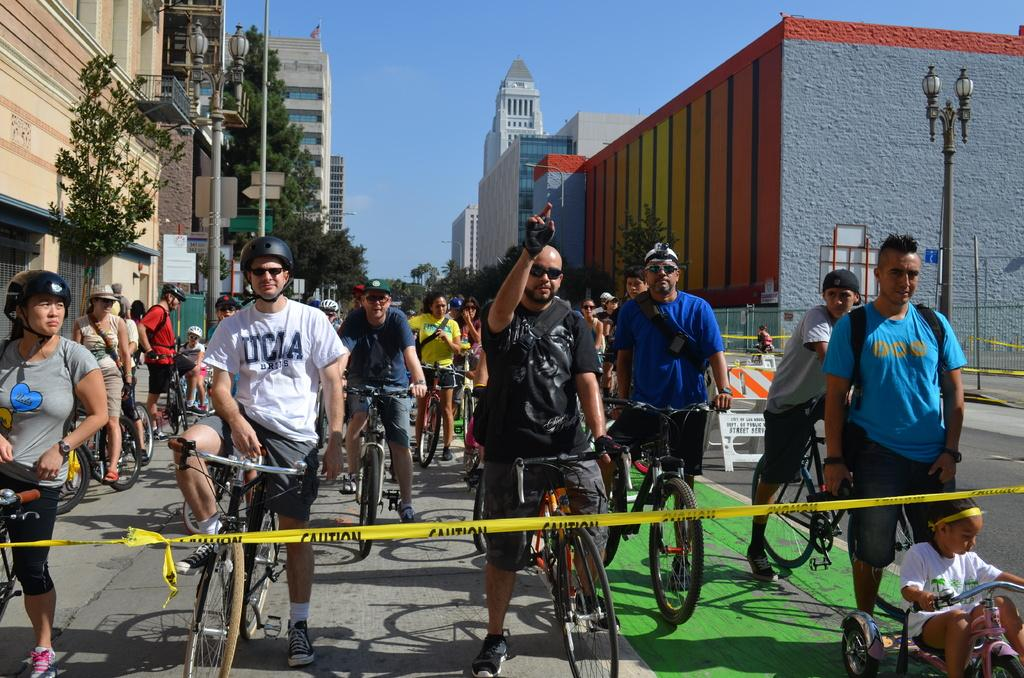What is happening in the image involving people? There is a group of people in the image, and they are standing on bicycles. What can be seen in the background of the image? There are trees and houses in the image. What is visible at the top of the image? The sky is visible at the top of the image. What type of brick is being used to knit a sock in the image? There is no brick or sock present in the image; it features a group of people standing on bicycles with trees, houses, and the sky visible in the background. 